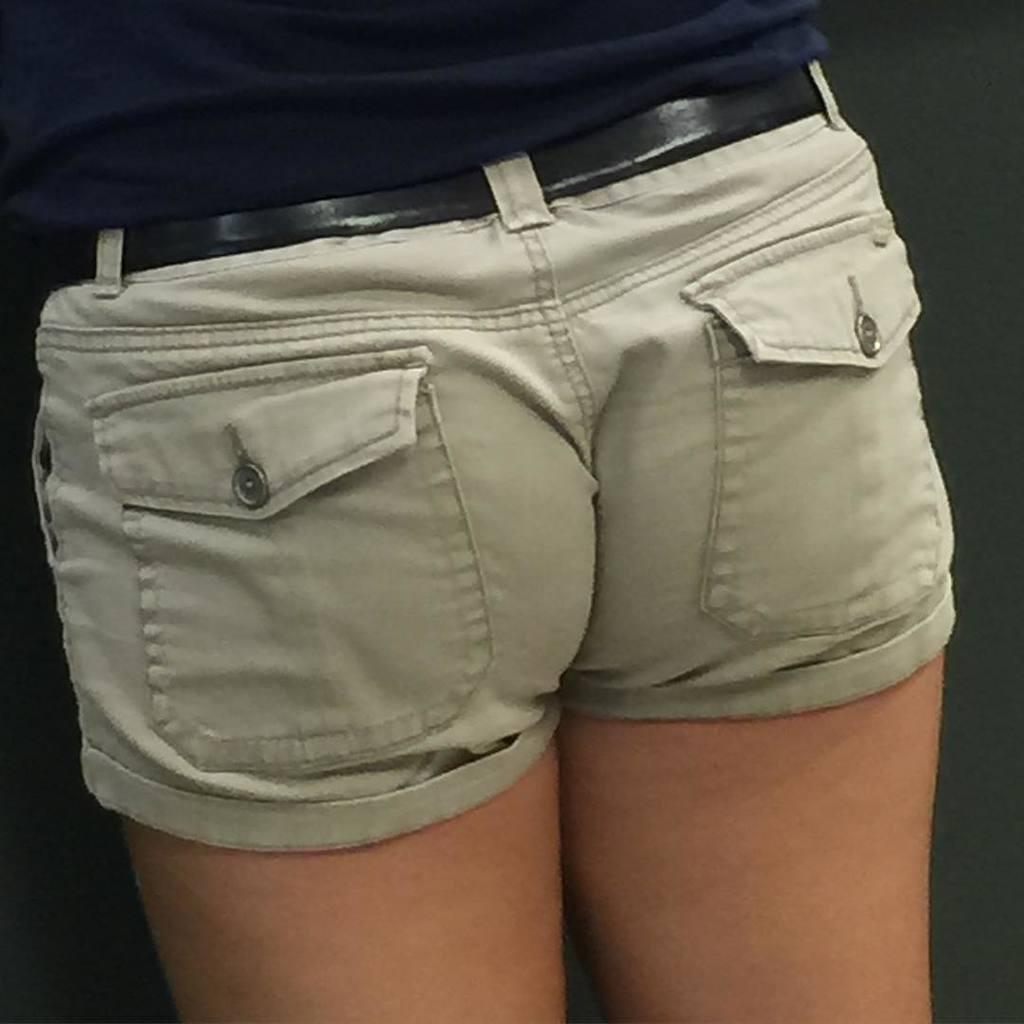Could you give a brief overview of what you see in this image? In this picture there is a person with dark blue t-shirt is standing. At the back it looks like a wall. 